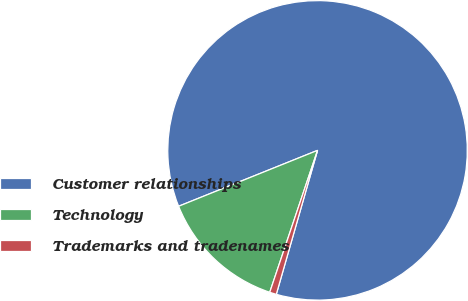Convert chart. <chart><loc_0><loc_0><loc_500><loc_500><pie_chart><fcel>Customer relationships<fcel>Technology<fcel>Trademarks and tradenames<nl><fcel>85.52%<fcel>13.74%<fcel>0.73%<nl></chart> 